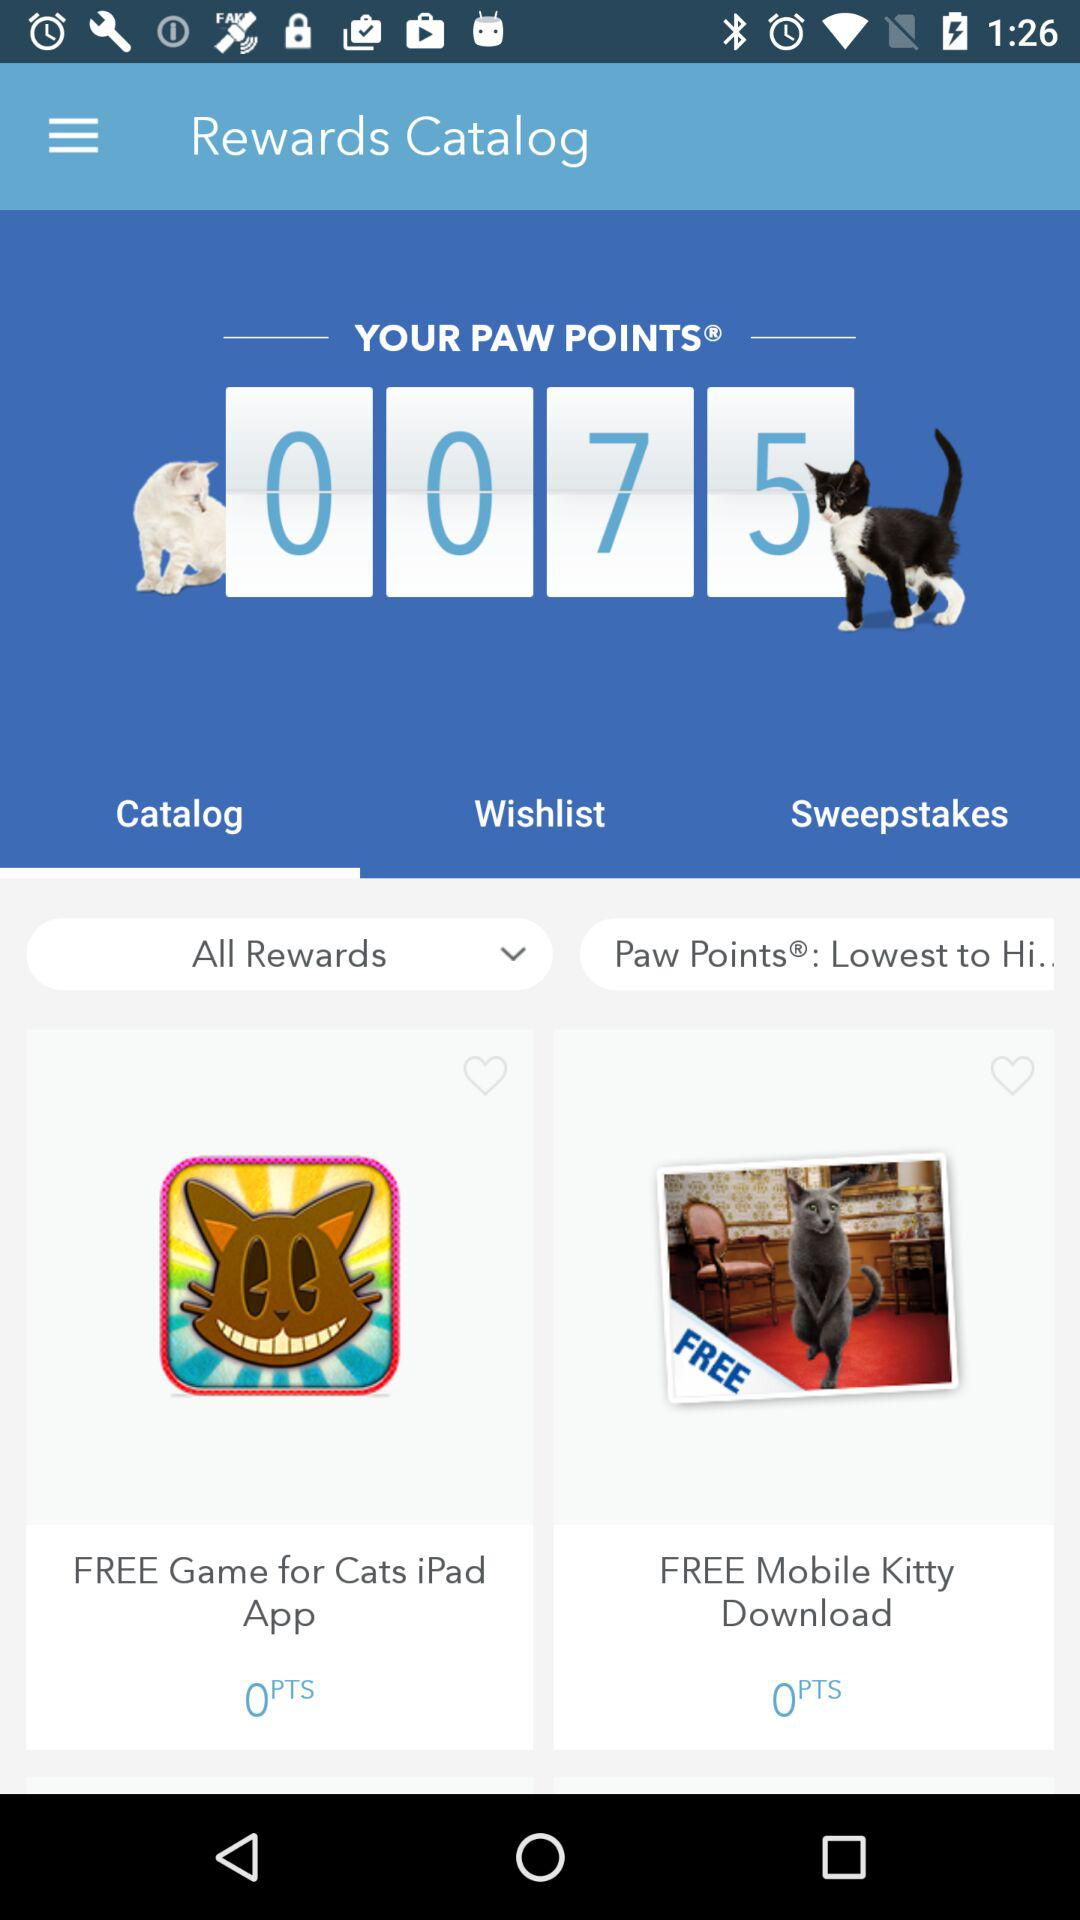Which tab is selected? The selected tab is "Catalog". 